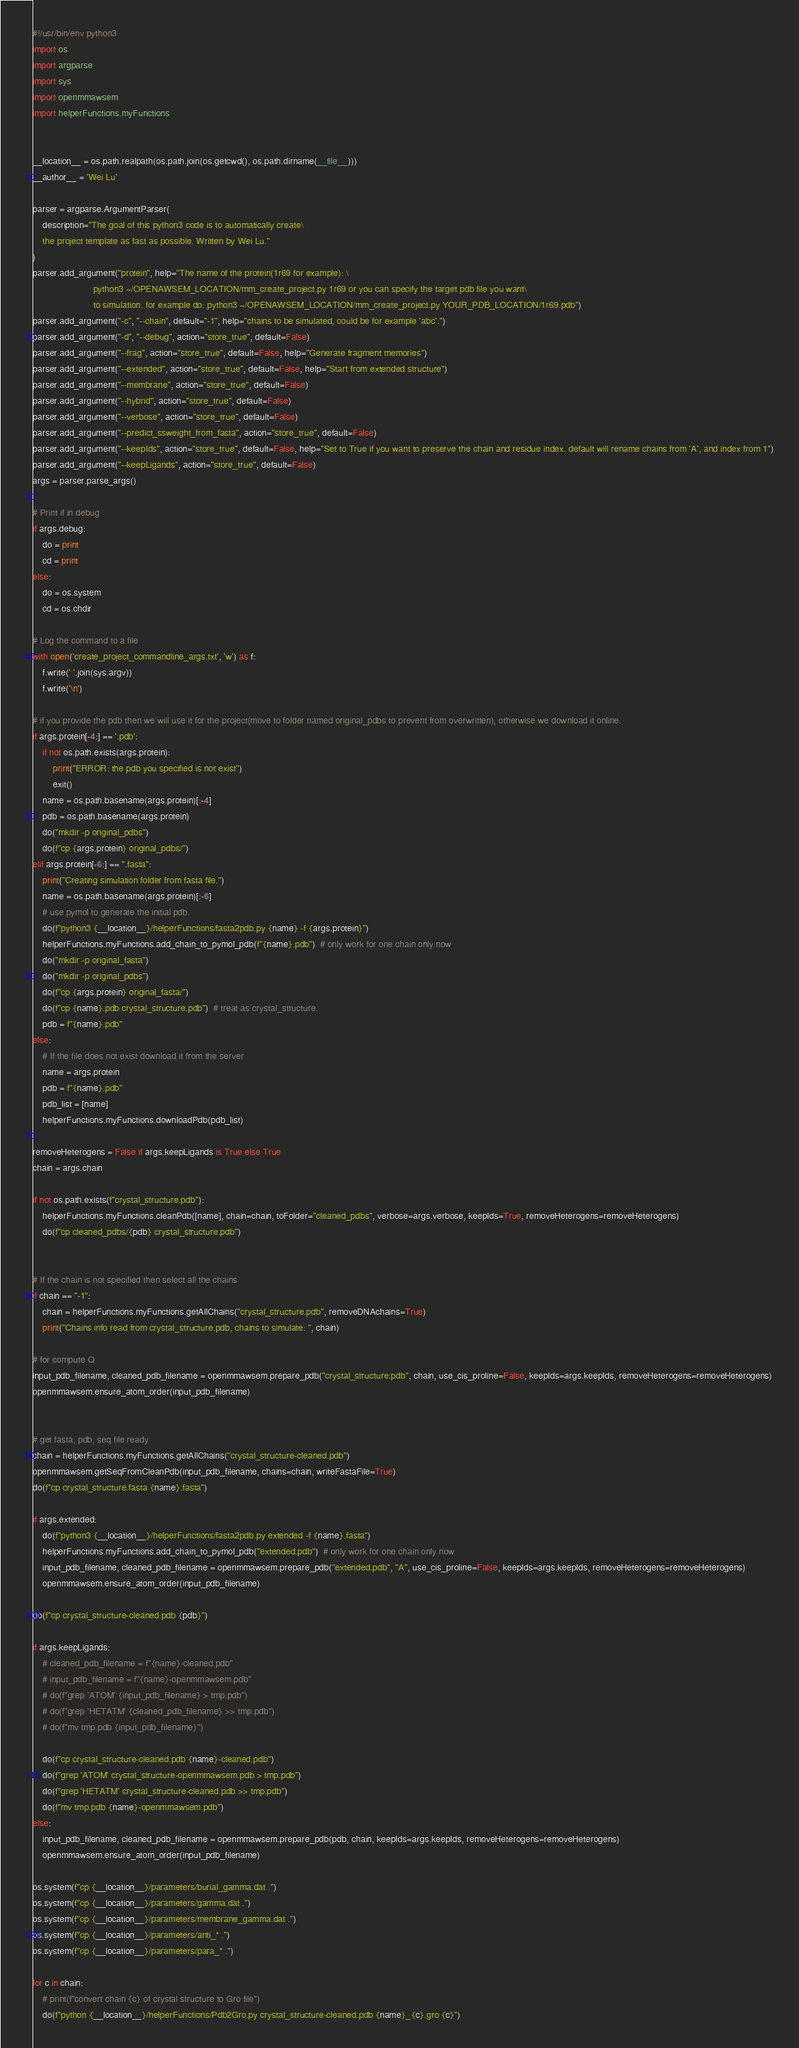<code> <loc_0><loc_0><loc_500><loc_500><_Python_>#!/usr/bin/env python3
import os
import argparse
import sys
import openmmawsem
import helperFunctions.myFunctions


__location__ = os.path.realpath(os.path.join(os.getcwd(), os.path.dirname(__file__)))
__author__ = 'Wei Lu'

parser = argparse.ArgumentParser(
    description="The goal of this python3 code is to automatically create\
    the project template as fast as possible. Written by Wei Lu."
)
parser.add_argument("protein", help="The name of the protein(1r69 for example): \
                        python3 ~/OPENAWSEM_LOCATION/mm_create_project.py 1r69 or you can specify the target pdb file you want\
                        to simulation. for example do: python3 ~/OPENAWSEM_LOCATION/mm_create_project.py YOUR_PDB_LOCATION/1r69.pdb")
parser.add_argument("-c", "--chain", default="-1", help="chains to be simulated, could be for example 'abc'.")
parser.add_argument("-d", "--debug", action="store_true", default=False)
parser.add_argument("--frag", action="store_true", default=False, help="Generate fragment memories")
parser.add_argument("--extended", action="store_true", default=False, help="Start from extended structure")
parser.add_argument("--membrane", action="store_true", default=False)
parser.add_argument("--hybrid", action="store_true", default=False)
parser.add_argument("--verbose", action="store_true", default=False)
parser.add_argument("--predict_ssweight_from_fasta", action="store_true", default=False)
parser.add_argument("--keepIds", action="store_true", default=False, help="Set to True if you want to preserve the chain and residue index. default will rename chains from 'A', and index from 1")
parser.add_argument("--keepLigands", action="store_true", default=False)
args = parser.parse_args()

# Print if in debug
if args.debug:
    do = print
    cd = print
else:
    do = os.system
    cd = os.chdir

# Log the command to a file
with open('create_project_commandline_args.txt', 'w') as f:
    f.write(' '.join(sys.argv))
    f.write('\n')

# if you provide the pdb then we will use it for the project(move to folder named original_pdbs to prevent from overwritten), otherwise we download it online.
if args.protein[-4:] == '.pdb':
    if not os.path.exists(args.protein):
        print("ERROR: the pdb you specified is not exist")
        exit()
    name = os.path.basename(args.protein)[:-4]
    pdb = os.path.basename(args.protein)
    do("mkdir -p original_pdbs")
    do(f"cp {args.protein} original_pdbs/")
elif args.protein[-6:] == ".fasta":
    print("Creating simulation folder from fasta file.")
    name = os.path.basename(args.protein)[:-6]
    # use pymol to generate the initial pdb.
    do(f"python3 {__location__}/helperFunctions/fasta2pdb.py {name} -f {args.protein}")
    helperFunctions.myFunctions.add_chain_to_pymol_pdb(f"{name}.pdb")  # only work for one chain only now
    do("mkdir -p original_fasta")
    do("mkdir -p original_pdbs")
    do(f"cp {args.protein} original_fasta/")
    do(f"cp {name}.pdb crystal_structure.pdb")  # treat as crystal_structure.
    pdb = f"{name}.pdb"
else:
    # If the file does not exist download it from the server
    name = args.protein
    pdb = f"{name}.pdb"
    pdb_list = [name]
    helperFunctions.myFunctions.downloadPdb(pdb_list)

removeHeterogens = False if args.keepLigands is True else True
chain = args.chain

if not os.path.exists(f"crystal_structure.pdb"):
    helperFunctions.myFunctions.cleanPdb([name], chain=chain, toFolder="cleaned_pdbs", verbose=args.verbose, keepIds=True, removeHeterogens=removeHeterogens)
    do(f"cp cleaned_pdbs/{pdb} crystal_structure.pdb")


# If the chain is not specified then select all the chains
if chain == "-1":
    chain = helperFunctions.myFunctions.getAllChains("crystal_structure.pdb", removeDNAchains=True)
    print("Chains info read from crystal_structure.pdb, chains to simulate: ", chain)

# for compute Q
input_pdb_filename, cleaned_pdb_filename = openmmawsem.prepare_pdb("crystal_structure.pdb", chain, use_cis_proline=False, keepIds=args.keepIds, removeHeterogens=removeHeterogens)
openmmawsem.ensure_atom_order(input_pdb_filename)


# get fasta, pdb, seq file ready
chain = helperFunctions.myFunctions.getAllChains("crystal_structure-cleaned.pdb")
openmmawsem.getSeqFromCleanPdb(input_pdb_filename, chains=chain, writeFastaFile=True)
do(f"cp crystal_structure.fasta {name}.fasta")

if args.extended:
    do(f"python3 {__location__}/helperFunctions/fasta2pdb.py extended -f {name}.fasta")
    helperFunctions.myFunctions.add_chain_to_pymol_pdb("extended.pdb")  # only work for one chain only now
    input_pdb_filename, cleaned_pdb_filename = openmmawsem.prepare_pdb("extended.pdb", "A", use_cis_proline=False, keepIds=args.keepIds, removeHeterogens=removeHeterogens)
    openmmawsem.ensure_atom_order(input_pdb_filename)

do(f"cp crystal_structure-cleaned.pdb {pdb}")

if args.keepLigands:
    # cleaned_pdb_filename = f"{name}-cleaned.pdb"
    # input_pdb_filename = f"{name}-openmmawsem.pdb"
    # do(f"grep 'ATOM' {input_pdb_filename} > tmp.pdb")
    # do(f"grep 'HETATM' {cleaned_pdb_filename} >> tmp.pdb")
    # do(f"mv tmp.pdb {input_pdb_filename}")

    do(f"cp crystal_structure-cleaned.pdb {name}-cleaned.pdb")
    do(f"grep 'ATOM' crystal_structure-openmmawsem.pdb > tmp.pdb")
    do(f"grep 'HETATM' crystal_structure-cleaned.pdb >> tmp.pdb")
    do(f"mv tmp.pdb {name}-openmmawsem.pdb")
else:
    input_pdb_filename, cleaned_pdb_filename = openmmawsem.prepare_pdb(pdb, chain, keepIds=args.keepIds, removeHeterogens=removeHeterogens)
    openmmawsem.ensure_atom_order(input_pdb_filename)

os.system(f"cp {__location__}/parameters/burial_gamma.dat .")
os.system(f"cp {__location__}/parameters/gamma.dat .")
os.system(f"cp {__location__}/parameters/membrane_gamma.dat .")
os.system(f"cp {__location__}/parameters/anti_* .")
os.system(f"cp {__location__}/parameters/para_* .")

for c in chain:
    # print(f"convert chain {c} of crystal structure to Gro file")
    do(f"python {__location__}/helperFunctions/Pdb2Gro.py crystal_structure-cleaned.pdb {name}_{c}.gro {c}")
</code> 